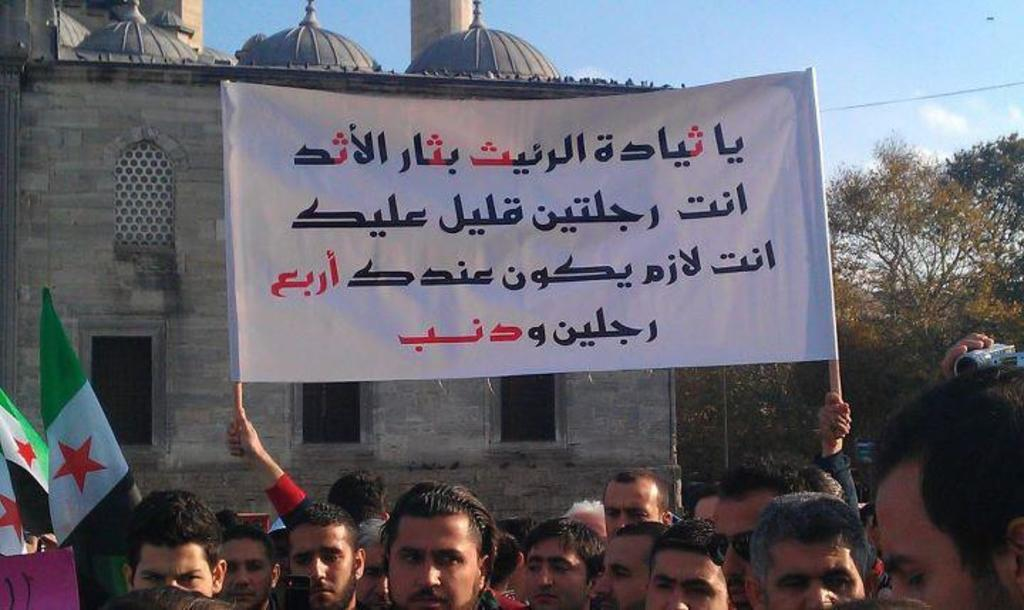How many people are in the group visible in the image? There is a group of people in the image, but the exact number cannot be determined from the provided facts. What is written on the banner in the image? The content of the banner cannot be determined from the provided facts. What colors are the flags in the image? The colors of the flags cannot be determined from the provided facts. What is the purpose of the camera in the image? The purpose of the camera in the image cannot be determined from the provided facts. What type of trees are in the image? The type of trees in the image cannot be determined from the provided facts. How many windows are on the building in the image? The number of windows on the building in the image cannot be determined from the provided facts. What type of clouds are visible in the sky in the background of the image? The type of clouds in the sky in the background of the image cannot be determined from the provided facts. What type of oatmeal is being served to the people in the image? There is no mention of oatmeal in the provided facts, and therefore it cannot be determined if it is present in the image. 